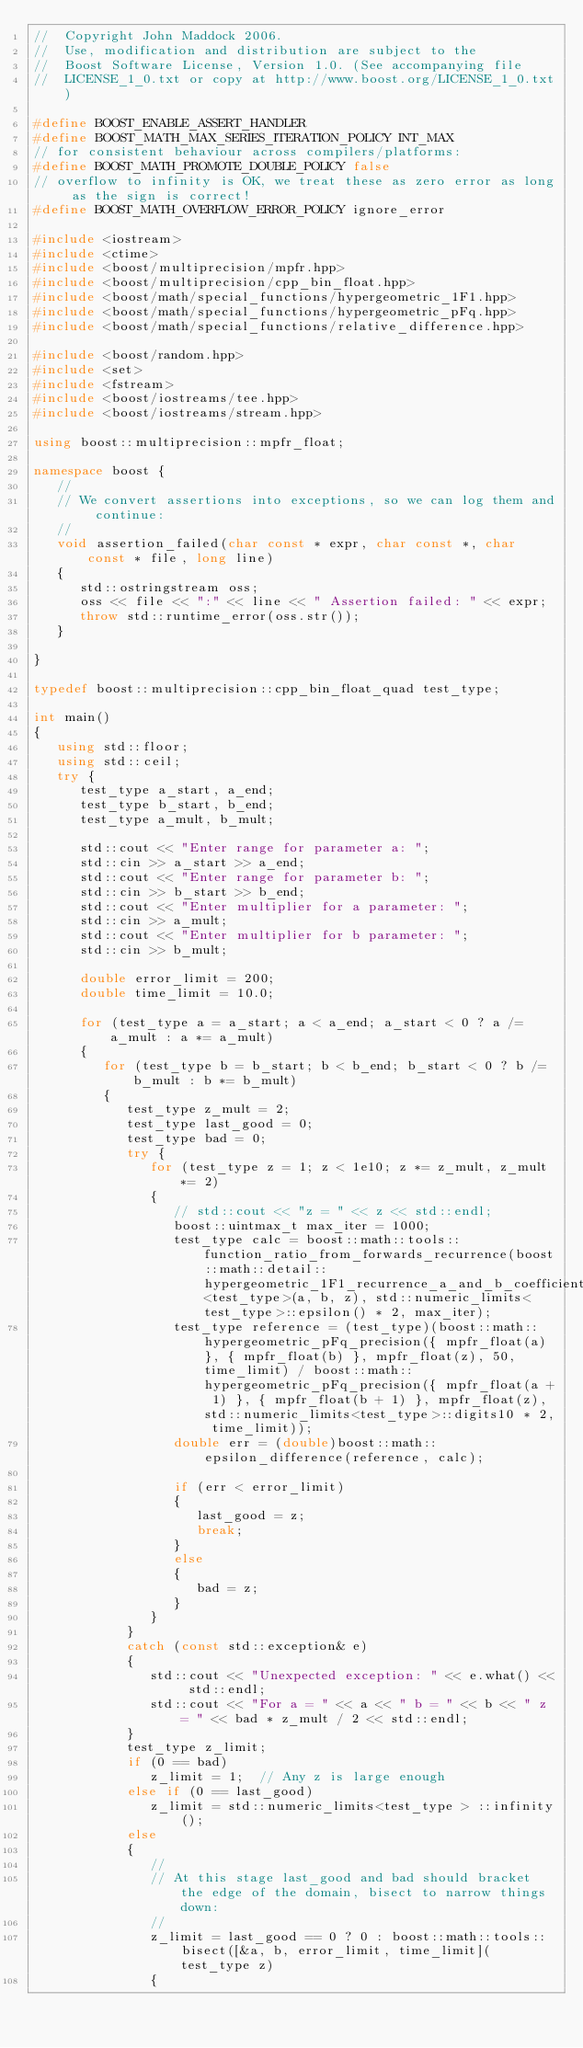<code> <loc_0><loc_0><loc_500><loc_500><_C++_>//  Copyright John Maddock 2006.
//  Use, modification and distribution are subject to the
//  Boost Software License, Version 1.0. (See accompanying file
//  LICENSE_1_0.txt or copy at http://www.boost.org/LICENSE_1_0.txt)

#define BOOST_ENABLE_ASSERT_HANDLER
#define BOOST_MATH_MAX_SERIES_ITERATION_POLICY INT_MAX
// for consistent behaviour across compilers/platforms:
#define BOOST_MATH_PROMOTE_DOUBLE_POLICY false
// overflow to infinity is OK, we treat these as zero error as long as the sign is correct!
#define BOOST_MATH_OVERFLOW_ERROR_POLICY ignore_error

#include <iostream>
#include <ctime>
#include <boost/multiprecision/mpfr.hpp>
#include <boost/multiprecision/cpp_bin_float.hpp>
#include <boost/math/special_functions/hypergeometric_1F1.hpp>
#include <boost/math/special_functions/hypergeometric_pFq.hpp>
#include <boost/math/special_functions/relative_difference.hpp>

#include <boost/random.hpp>
#include <set>
#include <fstream>
#include <boost/iostreams/tee.hpp>
#include <boost/iostreams/stream.hpp>

using boost::multiprecision::mpfr_float;

namespace boost {
   //
   // We convert assertions into exceptions, so we can log them and continue:
   //
   void assertion_failed(char const * expr, char const *, char const * file, long line)
   {
      std::ostringstream oss;
      oss << file << ":" << line << " Assertion failed: " << expr;
      throw std::runtime_error(oss.str());
   }

}

typedef boost::multiprecision::cpp_bin_float_quad test_type;

int main()
{
   using std::floor;
   using std::ceil;
   try {
      test_type a_start, a_end;
      test_type b_start, b_end;
      test_type a_mult, b_mult;

      std::cout << "Enter range for parameter a: ";
      std::cin >> a_start >> a_end;
      std::cout << "Enter range for parameter b: ";
      std::cin >> b_start >> b_end;
      std::cout << "Enter multiplier for a parameter: ";
      std::cin >> a_mult;
      std::cout << "Enter multiplier for b parameter: ";
      std::cin >> b_mult;

      double error_limit = 200;
      double time_limit = 10.0;

      for (test_type a = a_start; a < a_end; a_start < 0 ? a /= a_mult : a *= a_mult)
      {
         for (test_type b = b_start; b < b_end; b_start < 0 ? b /= b_mult : b *= b_mult)
         {
            test_type z_mult = 2;
            test_type last_good = 0;
            test_type bad = 0;
            try {
               for (test_type z = 1; z < 1e10; z *= z_mult, z_mult *= 2)
               {
                  // std::cout << "z = " << z << std::endl;
                  boost::uintmax_t max_iter = 1000;
                  test_type calc = boost::math::tools::function_ratio_from_forwards_recurrence(boost::math::detail::hypergeometric_1F1_recurrence_a_and_b_coefficients<test_type>(a, b, z), std::numeric_limits<test_type>::epsilon() * 2, max_iter);
                  test_type reference = (test_type)(boost::math::hypergeometric_pFq_precision({ mpfr_float(a) }, { mpfr_float(b) }, mpfr_float(z), 50, time_limit) / boost::math::hypergeometric_pFq_precision({ mpfr_float(a + 1) }, { mpfr_float(b + 1) }, mpfr_float(z), std::numeric_limits<test_type>::digits10 * 2, time_limit));
                  double err = (double)boost::math::epsilon_difference(reference, calc);

                  if (err < error_limit)
                  {
                     last_good = z;
                     break;
                  }
                  else
                  {
                     bad = z;
                  }
               }
            }
            catch (const std::exception& e)
            {
               std::cout << "Unexpected exception: " << e.what() << std::endl;
               std::cout << "For a = " << a << " b = " << b << " z = " << bad * z_mult / 2 << std::endl;
            }
            test_type z_limit;
            if (0 == bad)
               z_limit = 1;  // Any z is large enough
            else if (0 == last_good)
               z_limit = std::numeric_limits<test_type > ::infinity();
            else
            {
               //
               // At this stage last_good and bad should bracket the edge of the domain, bisect to narrow things down:
               //
               z_limit = last_good == 0 ? 0 : boost::math::tools::bisect([&a, b, error_limit, time_limit](test_type z)
               {</code> 